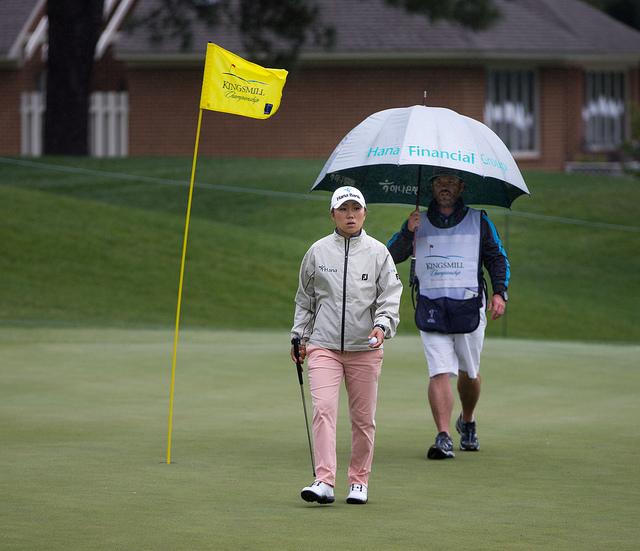What color is the umbrella?
Write a very short answer. White. Why is the man holding an umbrella?
Short answer required. Raining. Which one is the golfer?
Quick response, please. Woman. 